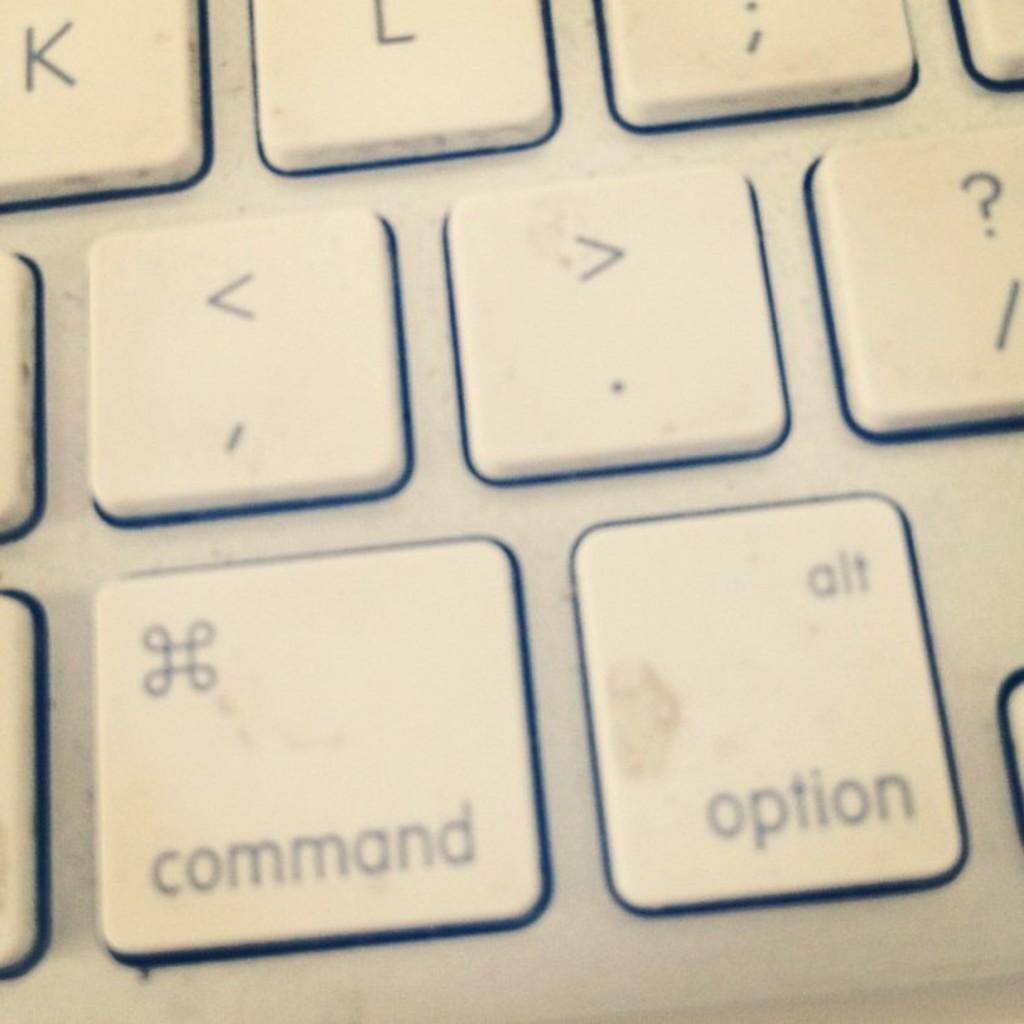Provide a one-sentence caption for the provided image. Close up on a mac keyboard showing the command, option and punctuation keys. 